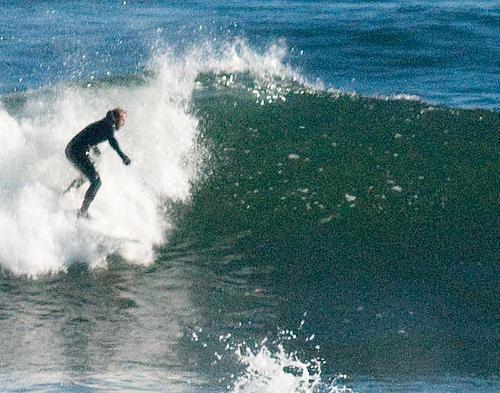How many people are in the photo?
Give a very brief answer. 1. 